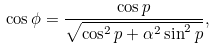<formula> <loc_0><loc_0><loc_500><loc_500>\cos { \phi } = \frac { \cos { p } } { \sqrt { \cos ^ { 2 } { p } + \alpha ^ { 2 } \sin ^ { 2 } { p } } } ,</formula> 